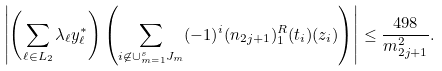<formula> <loc_0><loc_0><loc_500><loc_500>& \left | \left ( \sum _ { \ell \in L _ { 2 } } \lambda _ { \ell } y ^ { * } _ { \ell } \right ) \left ( \sum _ { i \not \in \cup _ { m = 1 } ^ { s } J _ { m } } ( - 1 ) ^ { i } ( n _ { 2 j + 1 } ) _ { 1 } ^ { R } ( t _ { i } ) ( z _ { i } ) \right ) \right | \leq \frac { 4 9 8 } { m ^ { 2 } _ { 2 j + 1 } } .</formula> 